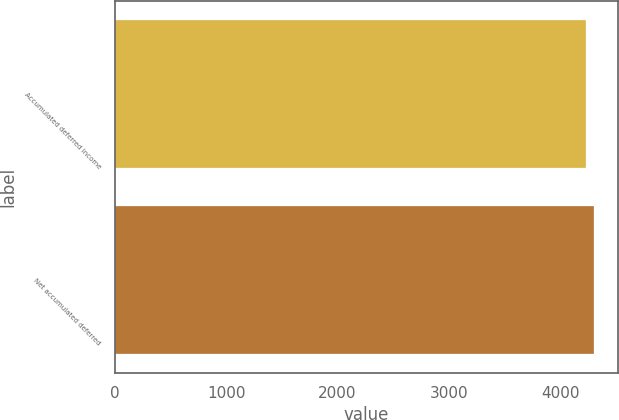Convert chart. <chart><loc_0><loc_0><loc_500><loc_500><bar_chart><fcel>Accumulated deferred income<fcel>Net accumulated deferred<nl><fcel>4231<fcel>4299<nl></chart> 